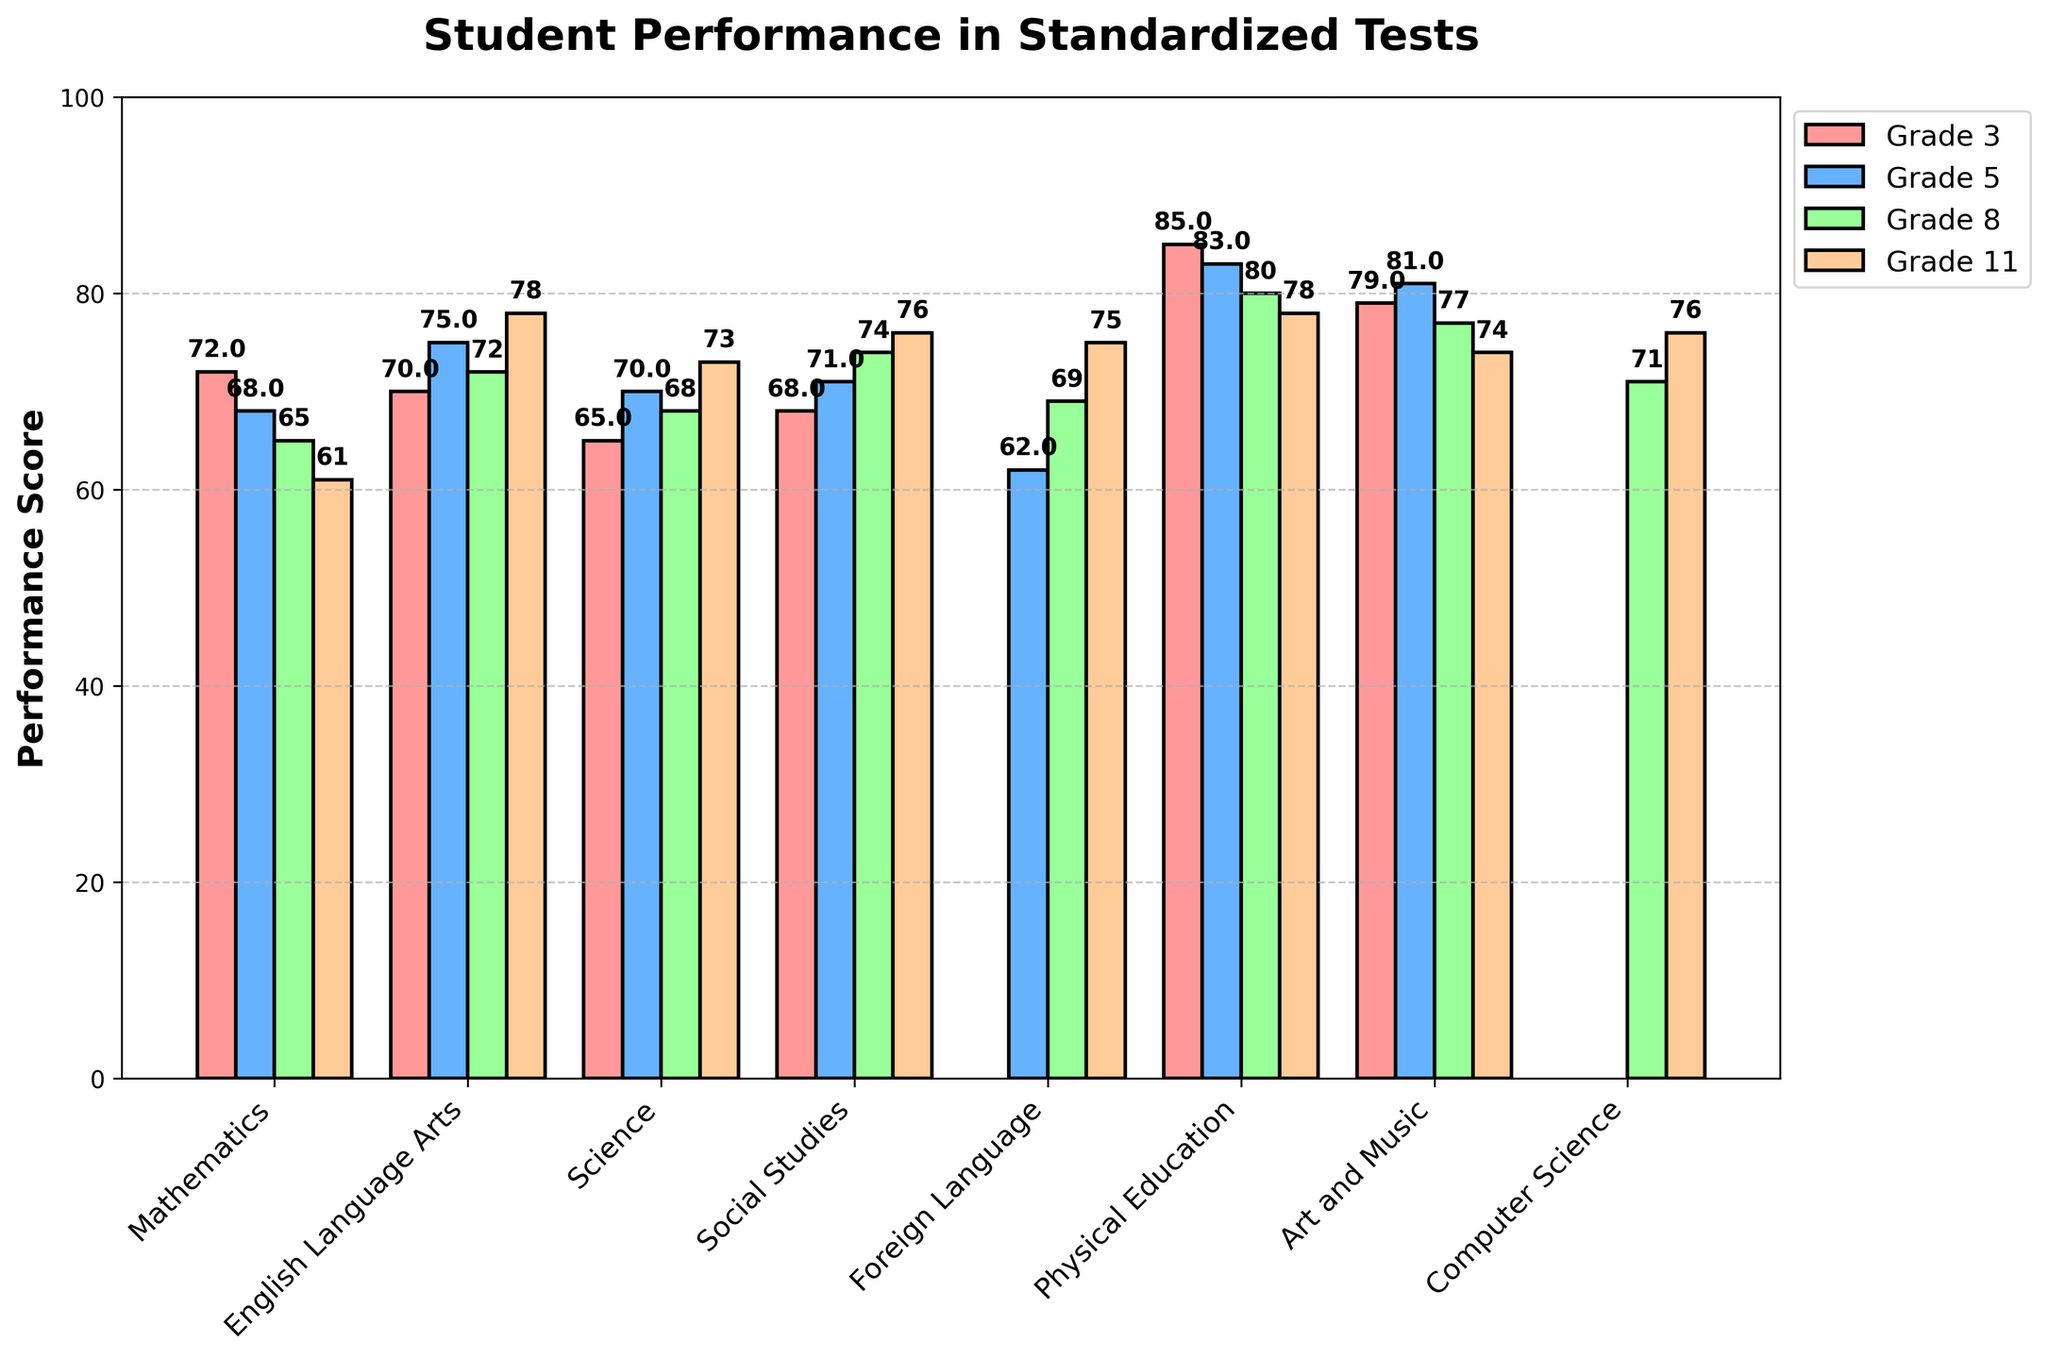Which grade has the highest performance score in Mathematics? By looking at the height of the bars in the mathematics category, Grade 3 has the highest performance score.
Answer: Grade 3 How does the performance score in English Language Arts change from Grade 3 to Grade 11? In the English Language Arts category, the scores are 70 for Grade 3, 75 for Grade 5, 72 for Grade 8, and 78 for Grade 11. Grade 11 has the highest score, indicating an increase overall.
Answer: Increases What is the average performance score for Science across all grades? The Science scores are: 65 (Grade 3), 70 (Grade 5), 68 (Grade 8), 73 (Grade 11). The average is (65 + 70 + 68 + 73) / 4 = 69.
Answer: 69 Which subject shows the most consistent performance scores across all grades? To determine consistency, look for the smallest variation in scores. Social Studies has scores of 68, 71, 74, and 76, which vary less than in other subjects.
Answer: Social Studies Between Grade 5 and Grade 8, which grade has better performance in Physical Education? Comparing the heights of the bars for Grade 5 and Grade 8 in the Physical Education category, Grade 5 has a score of 83 while Grade 8 has 80.
Answer: Grade 5 In which subject does Grade 11 perform the best? By comparing the height of the bars for Grade 11 across subjects, Physical Education has the highest score at 78.
Answer: Physical Education What is the total score for Foreign Language from Grade 5 to Grade 11? Adding the scores for Foreign Language: Grade 5 (62), Grade 8 (69), Grade 11 (75). Total = 62 + 69 + 75 = 206.
Answer: 206 Compare the performance trend in Art and Music from Grade 3 to Grade 11. The scores for Art and Music are: 79 (Grade 3), 81 (Grade 5), 77 (Grade 8), and 74 (Grade 11). The trend shows a decrease from Grade 5 to Grade 11.
Answer: Decreasing Which grade shows the greatest improvement in performance scores in any subject? English Language Arts for Grade 11 improves the most from 70 (Grade 3) to 78 (Grade 11), showing an improvement of 8.
Answer: Grade 11 in English Language Arts 